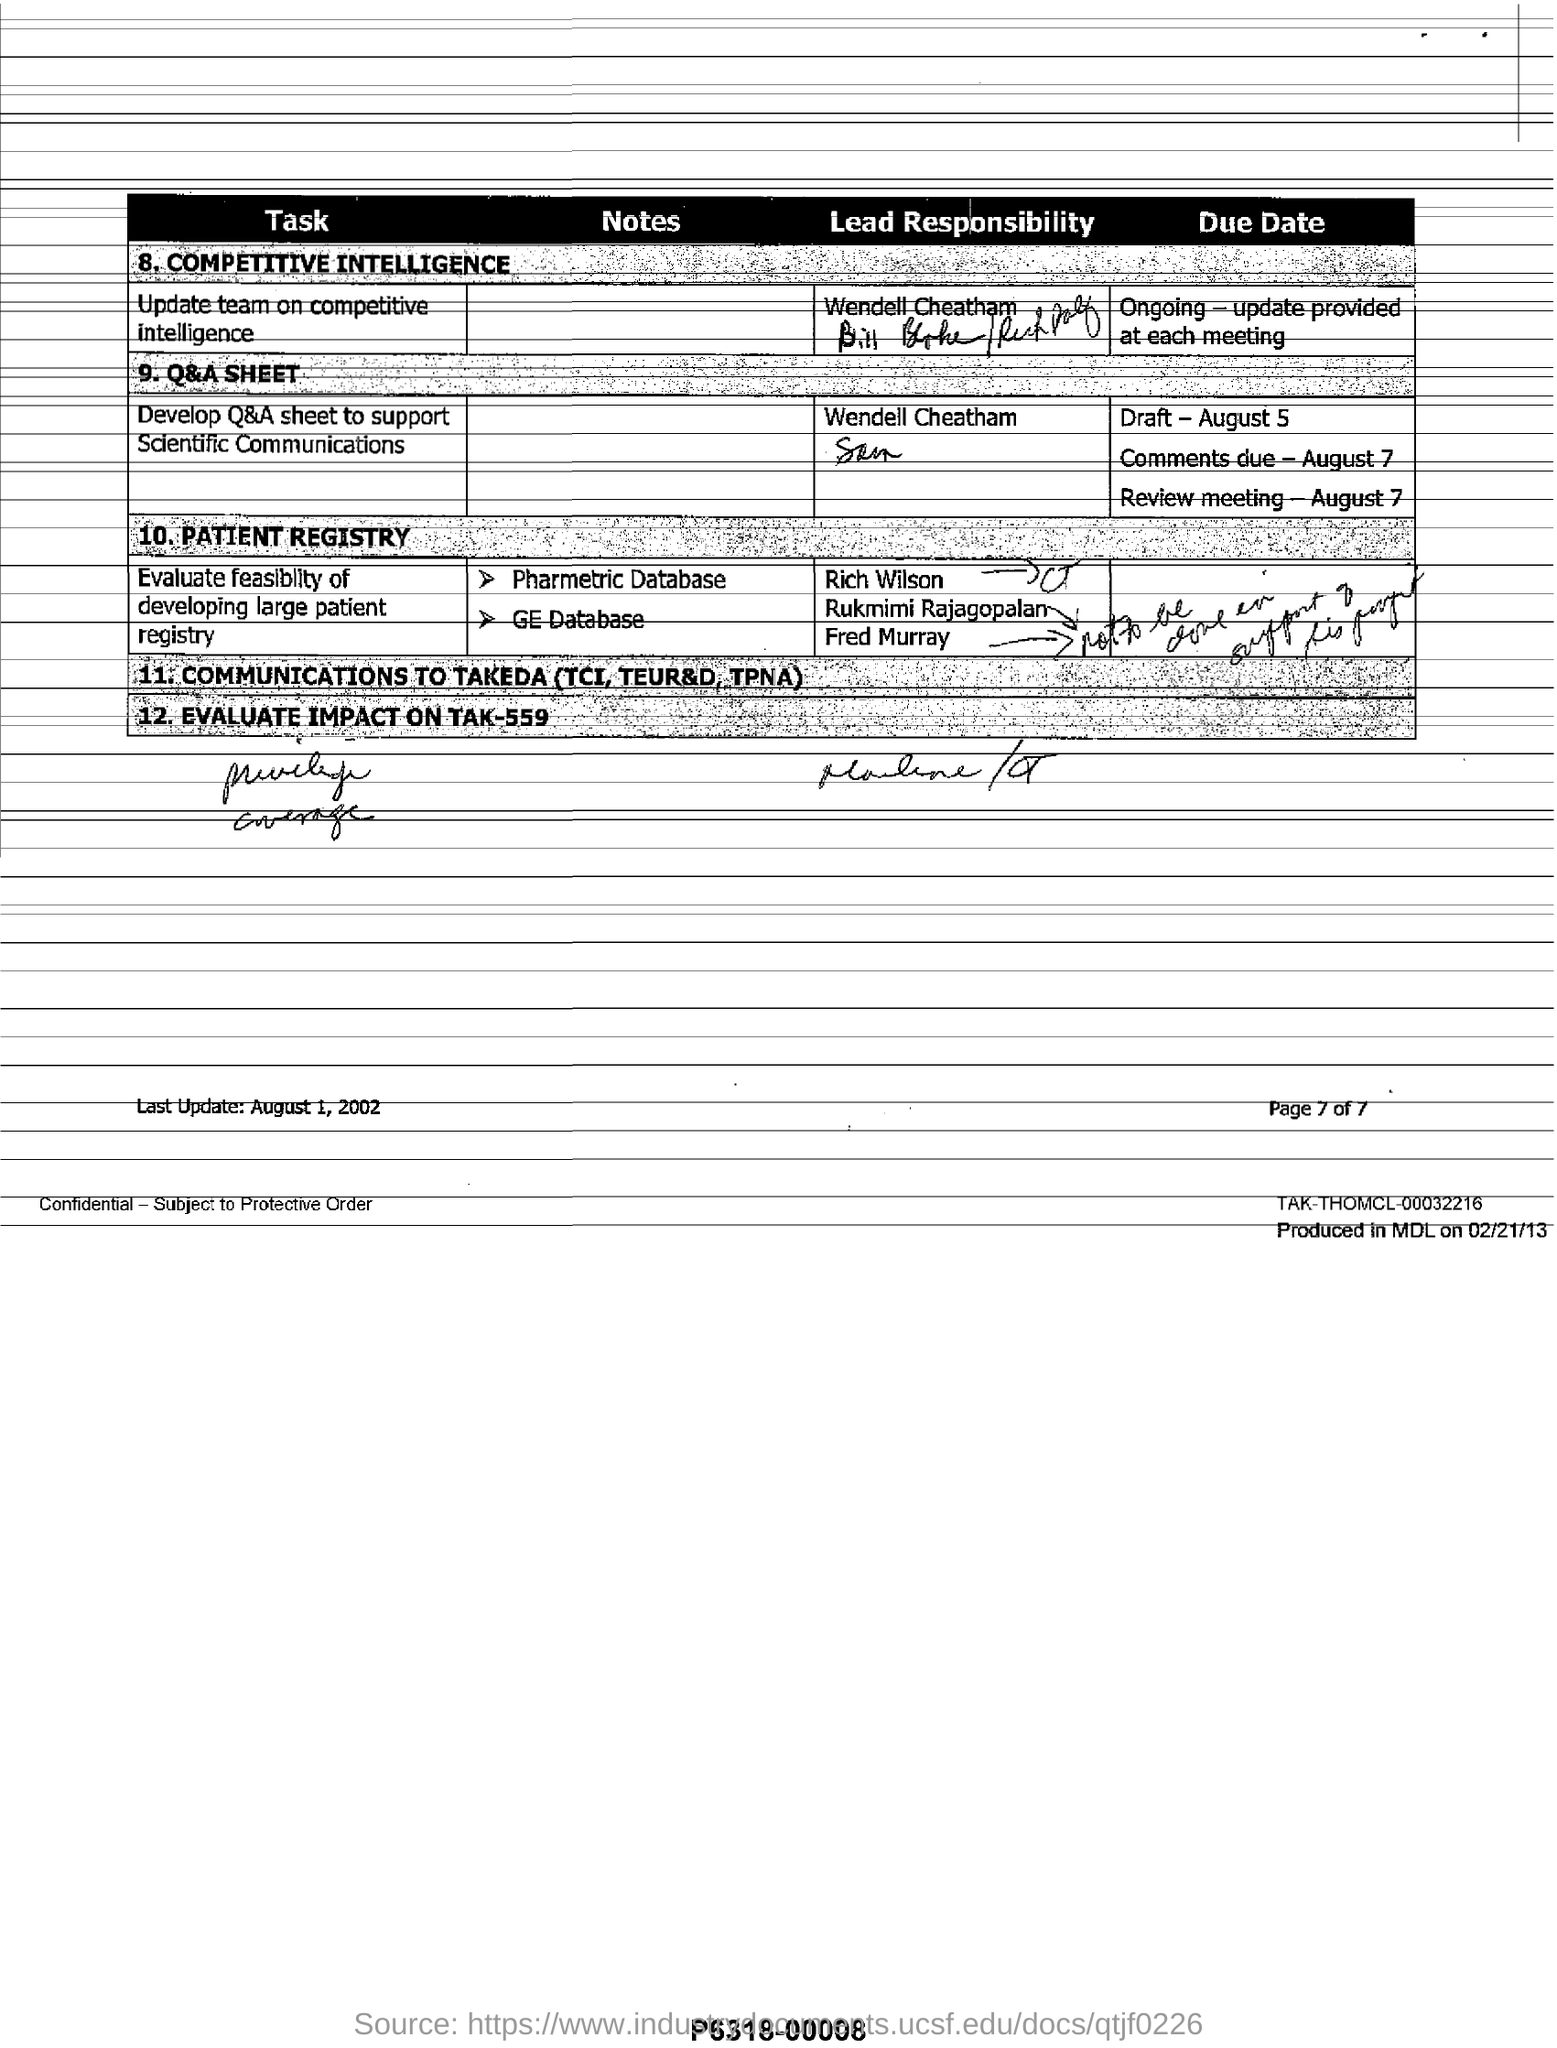Specify some key components in this picture. The last point in the table is the "Elevated glucose" condition with a p-value of 0.011. If the glucose concentration in the final wash was 10 mmol/L, the study would have 95% power to detect a difference in the number of CFU/mL of E. faecium between the "Tak-559" and "Tak-559&Ery-1% (w/v)" treatments of at least 3.22 log CFU/mL with a one-tailed t-test. The due date for the draft is August 5th. The document was last updated on August 1, 2002. 